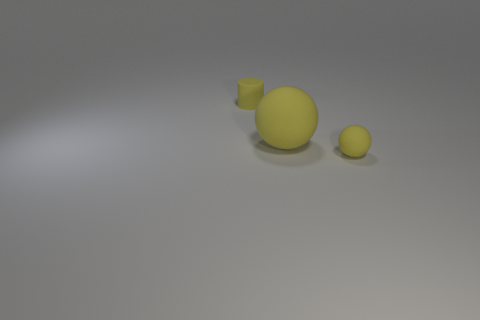What shape is the large thing that is the same color as the small matte cylinder?
Offer a very short reply. Sphere. There is a yellow ball that is behind the ball on the right side of the large yellow rubber thing; what size is it?
Your answer should be very brief. Large. There is a large matte thing behind the yellow object in front of the big matte sphere; is there a tiny matte thing left of it?
Ensure brevity in your answer.  Yes. What number of yellow spheres have the same size as the cylinder?
Offer a very short reply. 1. What material is the tiny yellow thing that is the same shape as the large matte object?
Make the answer very short. Rubber. There is a matte object that is both behind the tiny yellow ball and in front of the tiny matte cylinder; what shape is it?
Make the answer very short. Sphere. There is a small yellow thing in front of the tiny cylinder; what is its shape?
Make the answer very short. Sphere. How many small things are both to the right of the tiny rubber cylinder and to the left of the large thing?
Offer a terse response. 0. There is a cylinder; is its size the same as the rubber ball left of the tiny sphere?
Provide a short and direct response. No. What size is the yellow rubber sphere right of the rubber ball behind the small yellow rubber object in front of the yellow cylinder?
Keep it short and to the point. Small. 